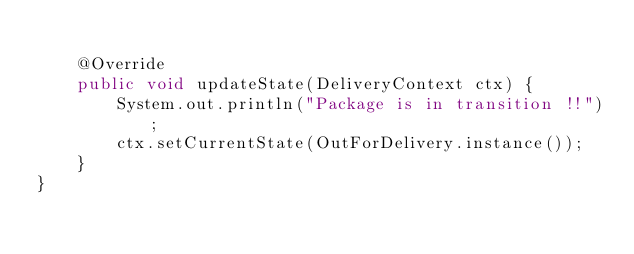<code> <loc_0><loc_0><loc_500><loc_500><_Java_>	
	@Override
	public void updateState(DeliveryContext ctx) {
		System.out.println("Package is in transition !!");
		ctx.setCurrentState(OutForDelivery.instance());
	}
}
</code> 